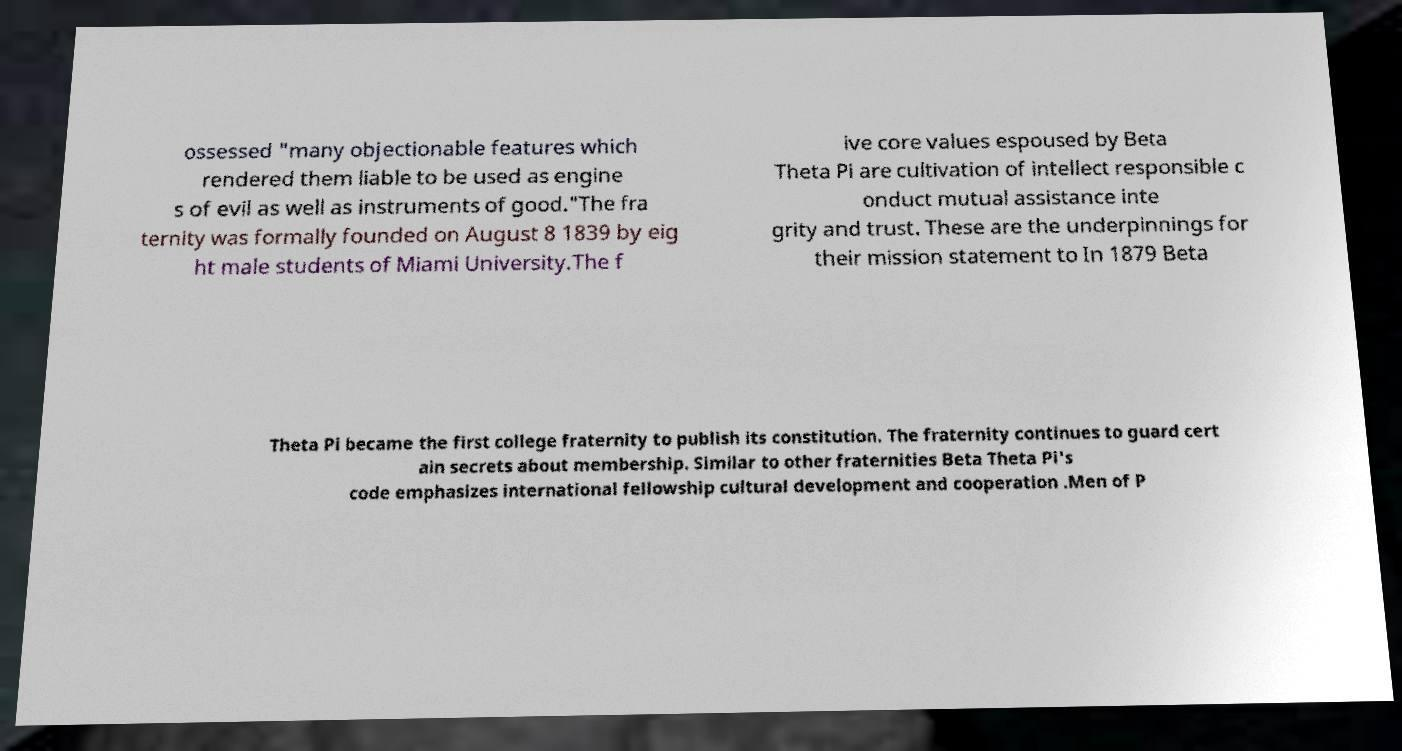Please read and relay the text visible in this image. What does it say? ossessed "many objectionable features which rendered them liable to be used as engine s of evil as well as instruments of good."The fra ternity was formally founded on August 8 1839 by eig ht male students of Miami University.The f ive core values espoused by Beta Theta Pi are cultivation of intellect responsible c onduct mutual assistance inte grity and trust. These are the underpinnings for their mission statement to In 1879 Beta Theta Pi became the first college fraternity to publish its constitution. The fraternity continues to guard cert ain secrets about membership. Similar to other fraternities Beta Theta Pi's code emphasizes international fellowship cultural development and cooperation .Men of P 